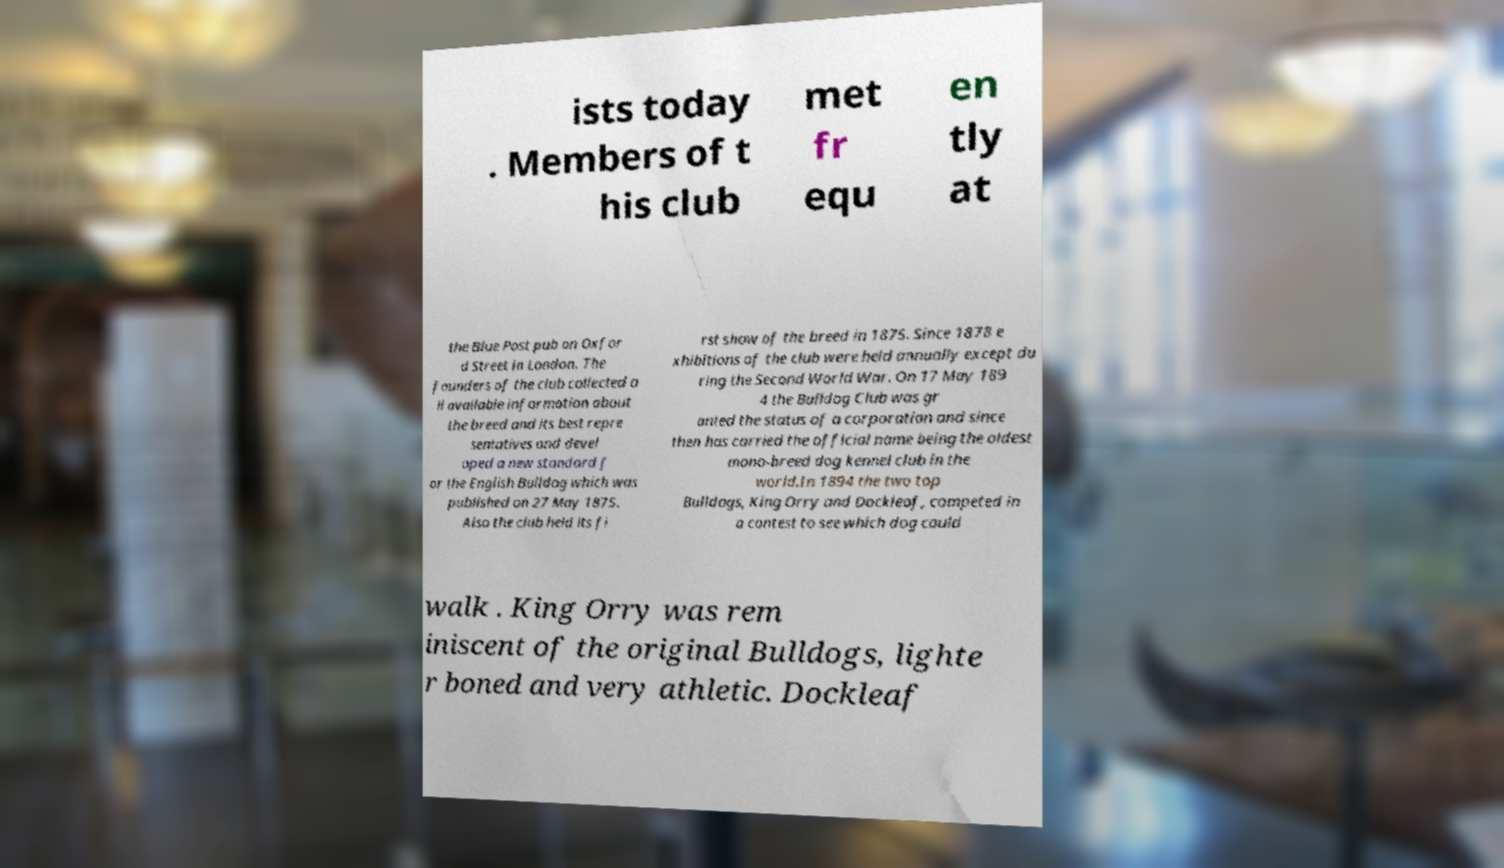Could you extract and type out the text from this image? ists today . Members of t his club met fr equ en tly at the Blue Post pub on Oxfor d Street in London. The founders of the club collected a ll available information about the breed and its best repre sentatives and devel oped a new standard f or the English Bulldog which was published on 27 May 1875. Also the club held its fi rst show of the breed in 1875. Since 1878 e xhibitions of the club were held annually except du ring the Second World War. On 17 May 189 4 the Bulldog Club was gr anted the status of a corporation and since then has carried the official name being the oldest mono-breed dog kennel club in the world.In 1894 the two top Bulldogs, King Orry and Dockleaf, competed in a contest to see which dog could walk . King Orry was rem iniscent of the original Bulldogs, lighte r boned and very athletic. Dockleaf 